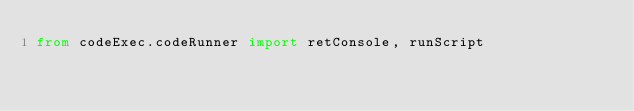Convert code to text. <code><loc_0><loc_0><loc_500><loc_500><_Python_>from codeExec.codeRunner import retConsole, runScript</code> 